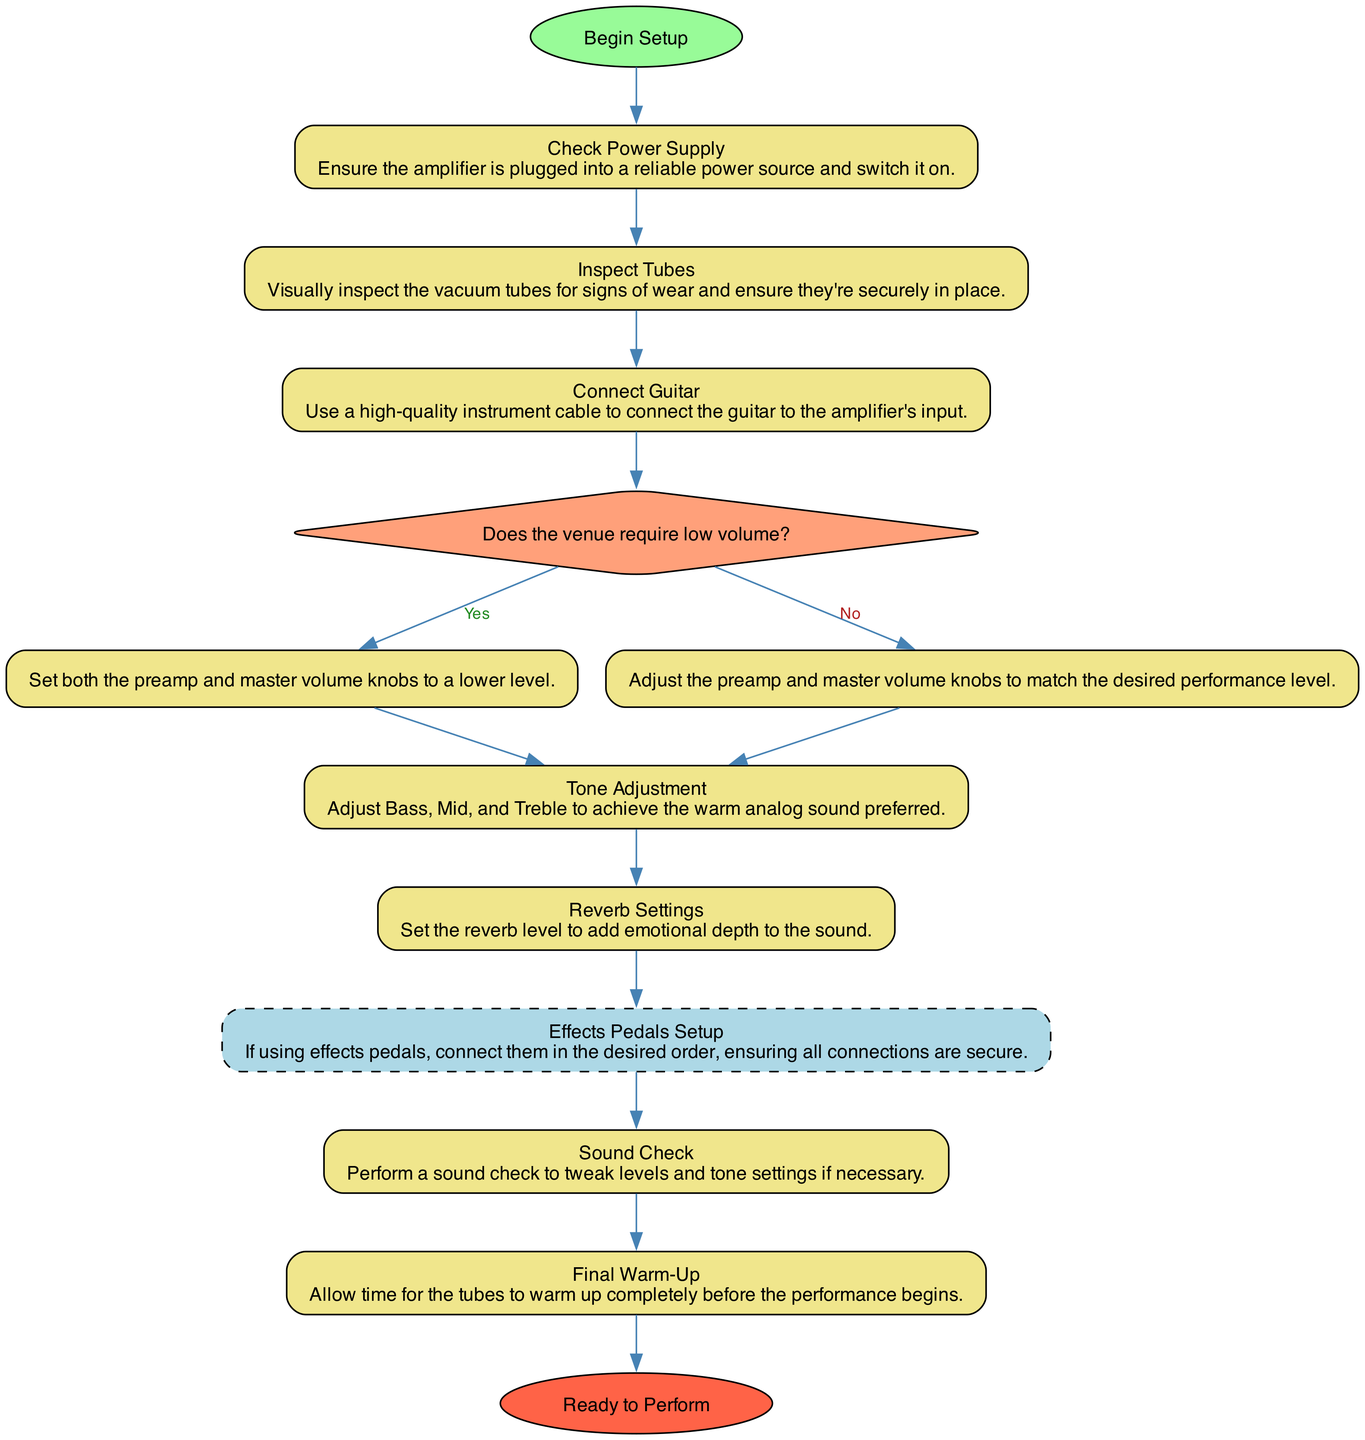What is the starting point of the flowchart? The starting point of the flowchart is denoted by the "Start" node, labeled "Begin Setup". This means the first action in the setup process begins at this point.
Answer: Begin Setup How many decision nodes are present in the flowchart? By counting the nodes in the diagram, we can see there is one decision node titled "Set Volume Knobs". Therefore, the total number of decision nodes is one.
Answer: 1 What is the last step before "Ready to Perform"? The last step before "Ready to Perform" is "Final Warm-Up". This is the penultimate action that needs to be completed before the performance readiness.
Answer: Final Warm-Up What do you need to do if the venue requires low volume? If the venue requires low volume, the process indicates to "Set both the preamp and master volume knobs to a lower level." This is a direct outcome of the decision made at the "Set Volume Knobs" node.
Answer: Set both the preamp and master volume knobs to a lower level What is the purpose of the "Reverb Settings" step? The purpose of the "Reverb Settings" step is to "Set the reverb level to add emotional depth to the sound". This indicates that adjustment here specifically enhances the overall tone during the performance.
Answer: Set the reverb level to add emotional depth to the sound What happens after connecting the guitar? After connecting the guitar, the next step is making a decision regarding the volume settings, titled "Set Volume Knobs". This indicates the progression from the basic connection phase to adjusting for venue requirements.
Answer: Set Volume Knobs What is the type of the "Effects Pedals Setup"? The "Effects Pedals Setup" is classified as a "Subprocess" in the flowchart. This indicates that it is a part of the overall setup process but treated as a distinct, expandable step.
Answer: Subprocess Which step focuses on achieving warm analog sound? The step focused on achieving warm analog sound is "Tone Adjustment", where Bass, Mid, and Treble are adjusted. This step emphasizes refining the sound quality to fit the desired warmth and depth.
Answer: Tone Adjustment 